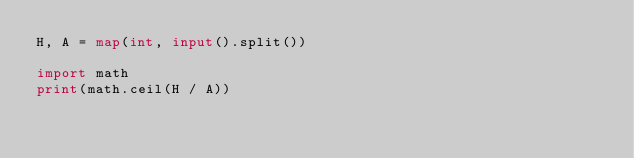<code> <loc_0><loc_0><loc_500><loc_500><_Python_>H, A = map(int, input().split())

import math
print(math.ceil(H / A))</code> 